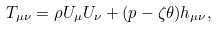<formula> <loc_0><loc_0><loc_500><loc_500>T _ { \mu \nu } = \rho U _ { \mu } U _ { \nu } + ( p - \zeta \theta ) h _ { \mu \nu } ,</formula> 